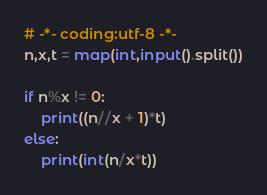Convert code to text. <code><loc_0><loc_0><loc_500><loc_500><_Python_># -*- coding:utf-8 -*-
n,x,t = map(int,input().split())

if n%x != 0:
    print((n//x + 1)*t)
else:
    print(int(n/x*t))</code> 